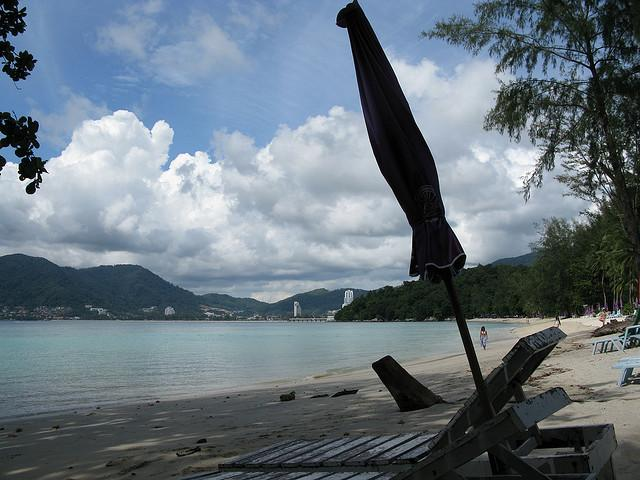What might this umbrella normally be used for?

Choices:
A) signaling
B) rain protection
C) nothing
D) sun protection sun protection 